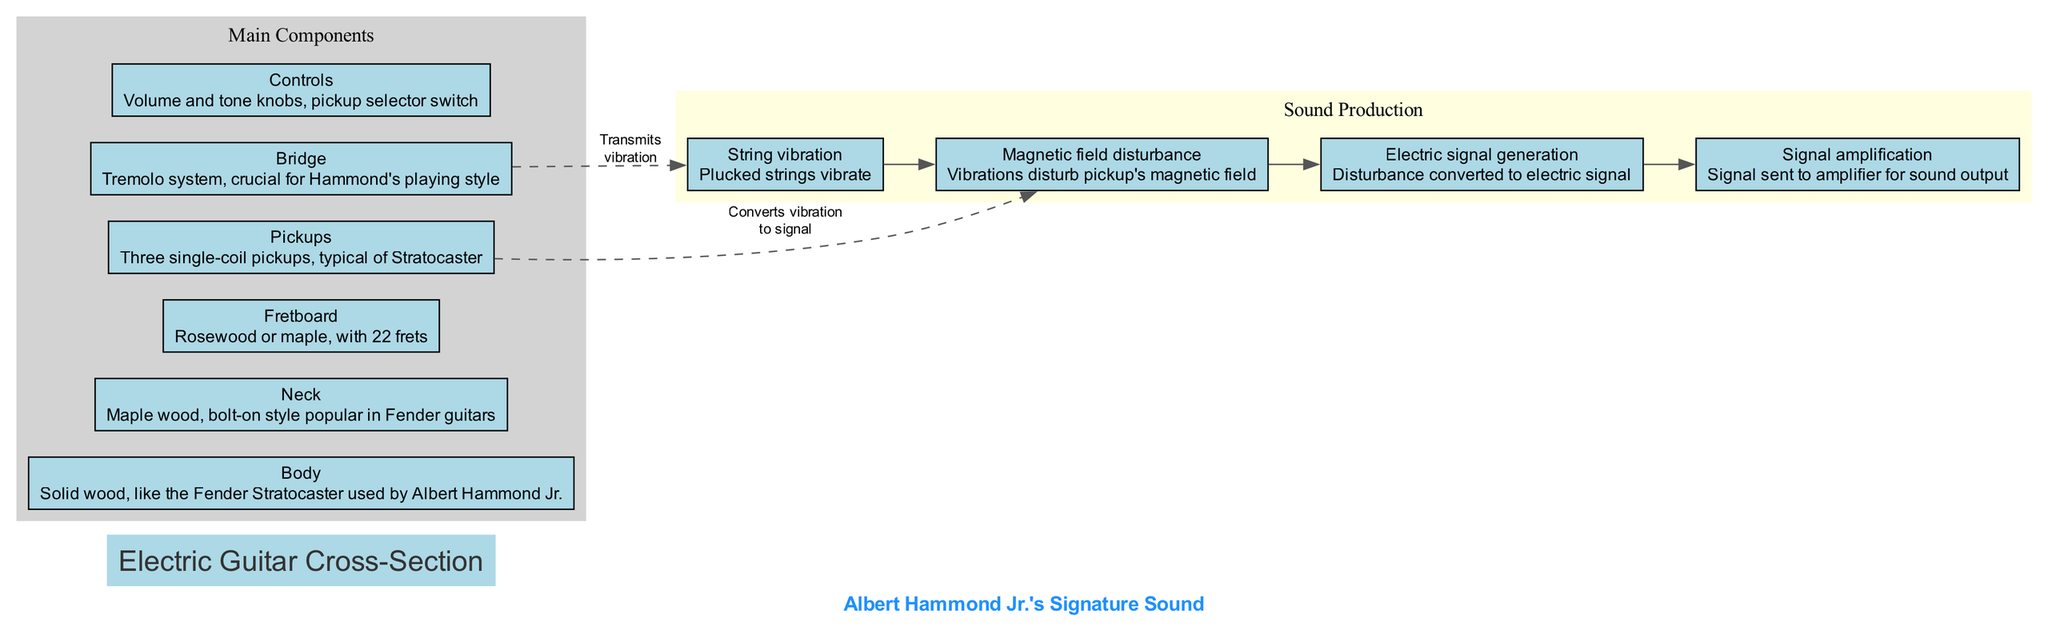What is the main component that provides the body of the guitar? The body of the guitar is noted as made of solid wood, specifically mentioned as something like the Fender Stratocaster used by Albert Hammond Jr. Hence, it serves as the main structural part of the instrument.
Answer: Body How many pickups are highlighted in the diagram? Upon examining the components section of the diagram, it shows three single-coil pickups, which are a typical feature of the Stratocaster.
Answer: Three What is the first step in sound production? The sound production section lists several steps sequentially. The first step mentioned is "String vibration", indicating that plucked strings vibrate to initiate the sound production process.
Answer: String vibration What connects the bridge to the sound production process? A dashed line labeled "Transmits vibration" indicates the connection from the bridge to the first step in sound production, highlighting its role in signaling the vibrations through the strings.
Answer: Transmits vibration Which wood type is mentioned for the neck of the guitar? The description in the diagram specifies that the neck is made of maple wood, which is common in many guitars, particularly in the Fender models.
Answer: Maple wood What is the last step in the sound production process? The steps in the sound production section are laid out in order, with the last step noted as "Signal amplification", indicating the role of an amplifier in outputting sound from the guitar.
Answer: Signal amplification Which component has volume and tone knobs? The controls section of the diagram specifically describes that it includes the volume and tone knobs along with a pickup selector switch, which are crucial for adjusting sound output characteristics.
Answer: Controls How is the disturbance in the magnetic field created? The diagram explains that string vibration disturbs the pickup's magnetic field, establishing the basis for generating an electrical signal as part of the sound production.
Answer: Disturbs pickup's magnetic field 